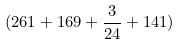<formula> <loc_0><loc_0><loc_500><loc_500>( 2 6 1 + 1 6 9 + \frac { 3 } { 2 4 } + 1 4 1 )</formula> 